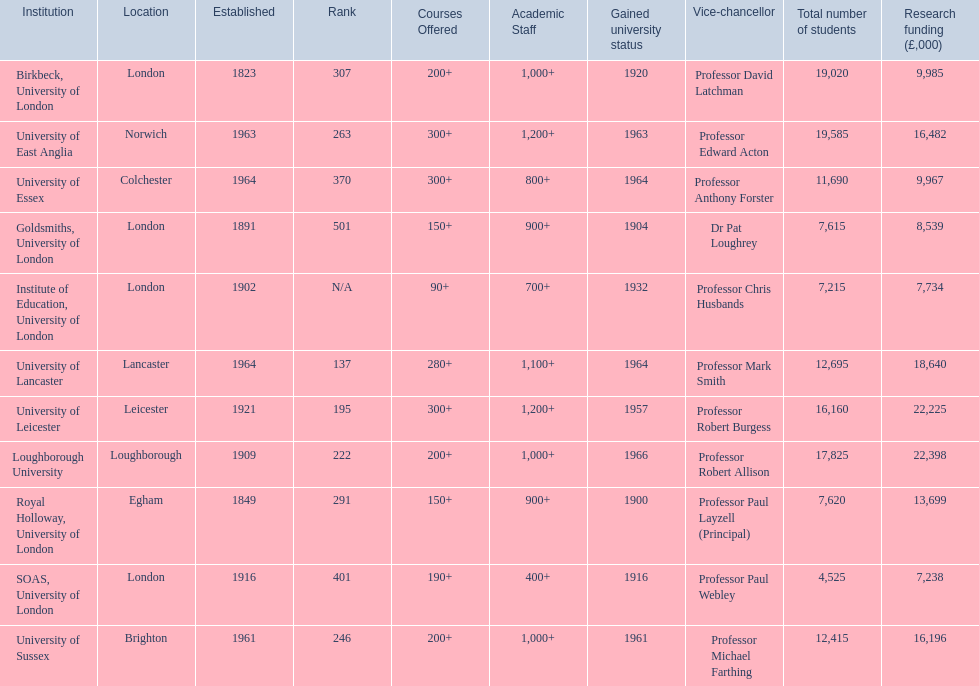Where is birbeck,university of london located? London. Which university was established in 1921? University of Leicester. Which institution gained university status recently? Loughborough University. 